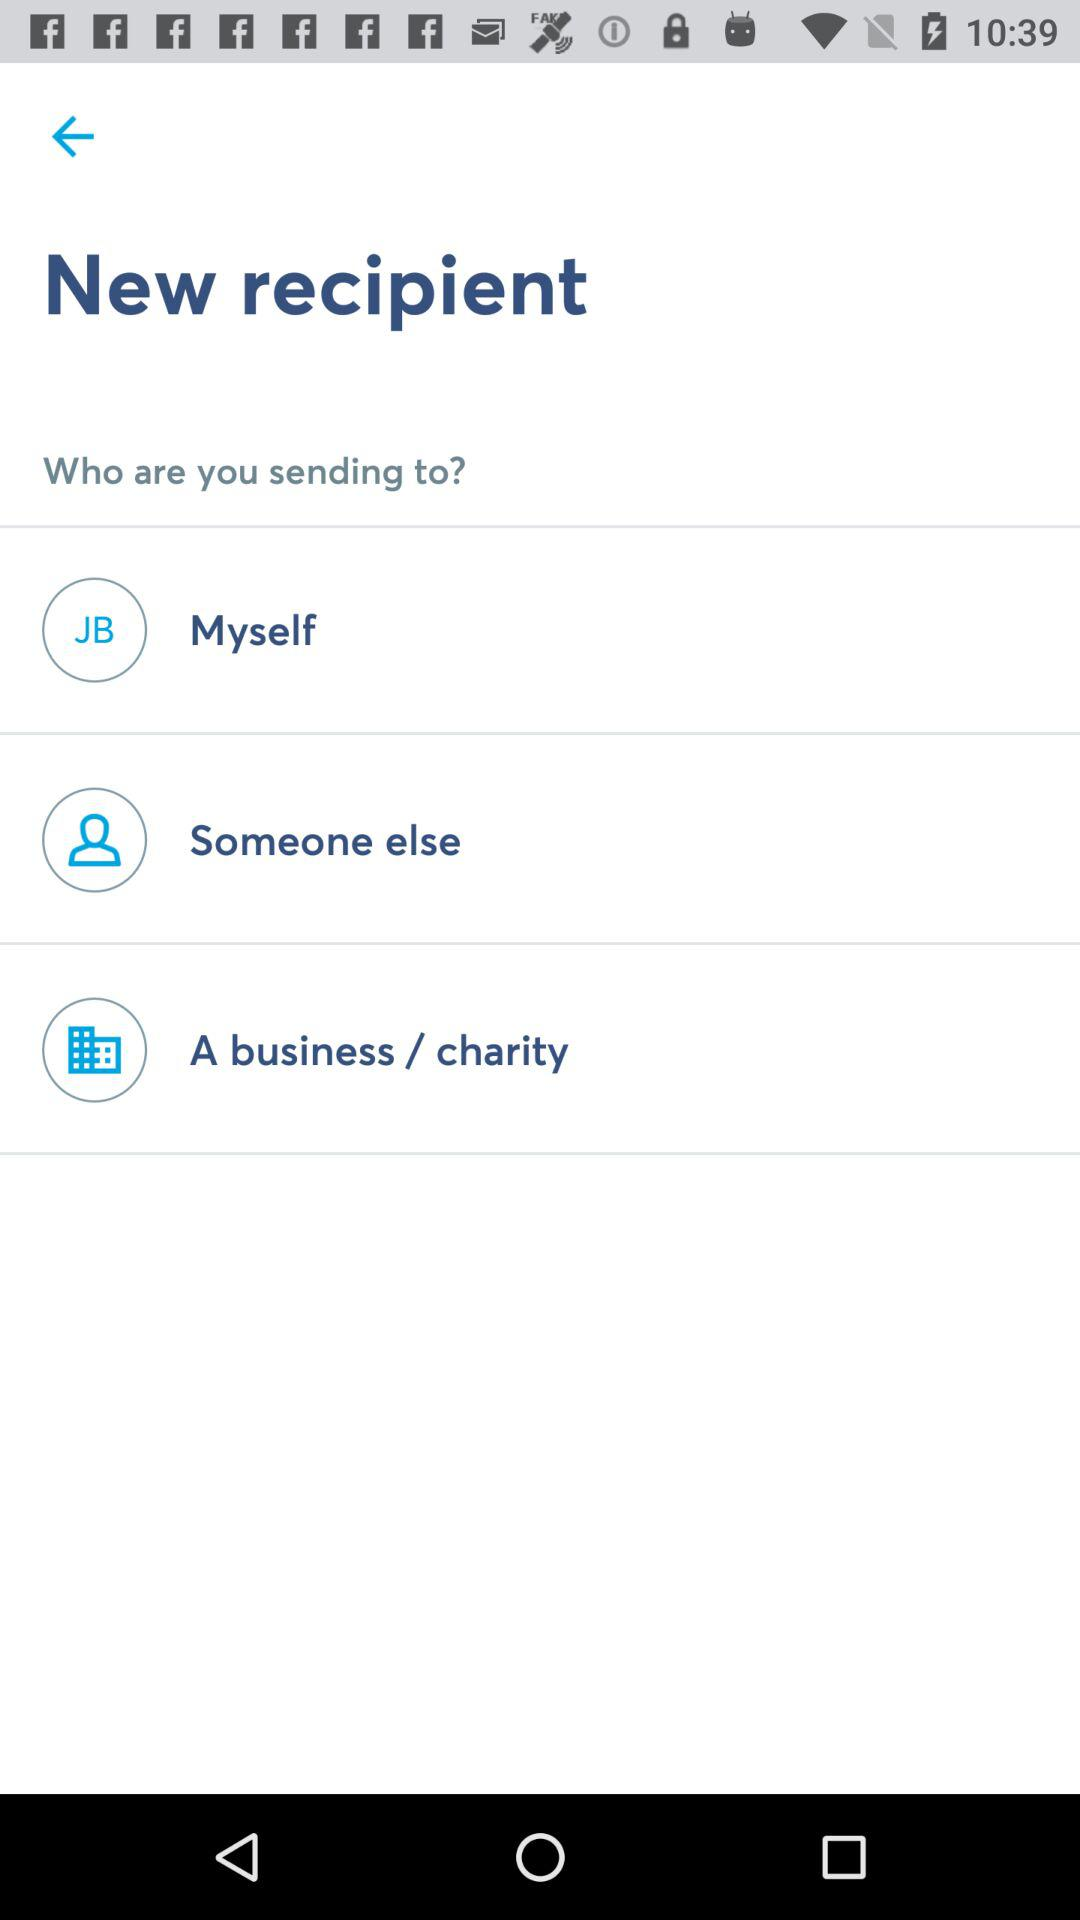How many options are there to select a recipient?
Answer the question using a single word or phrase. 3 